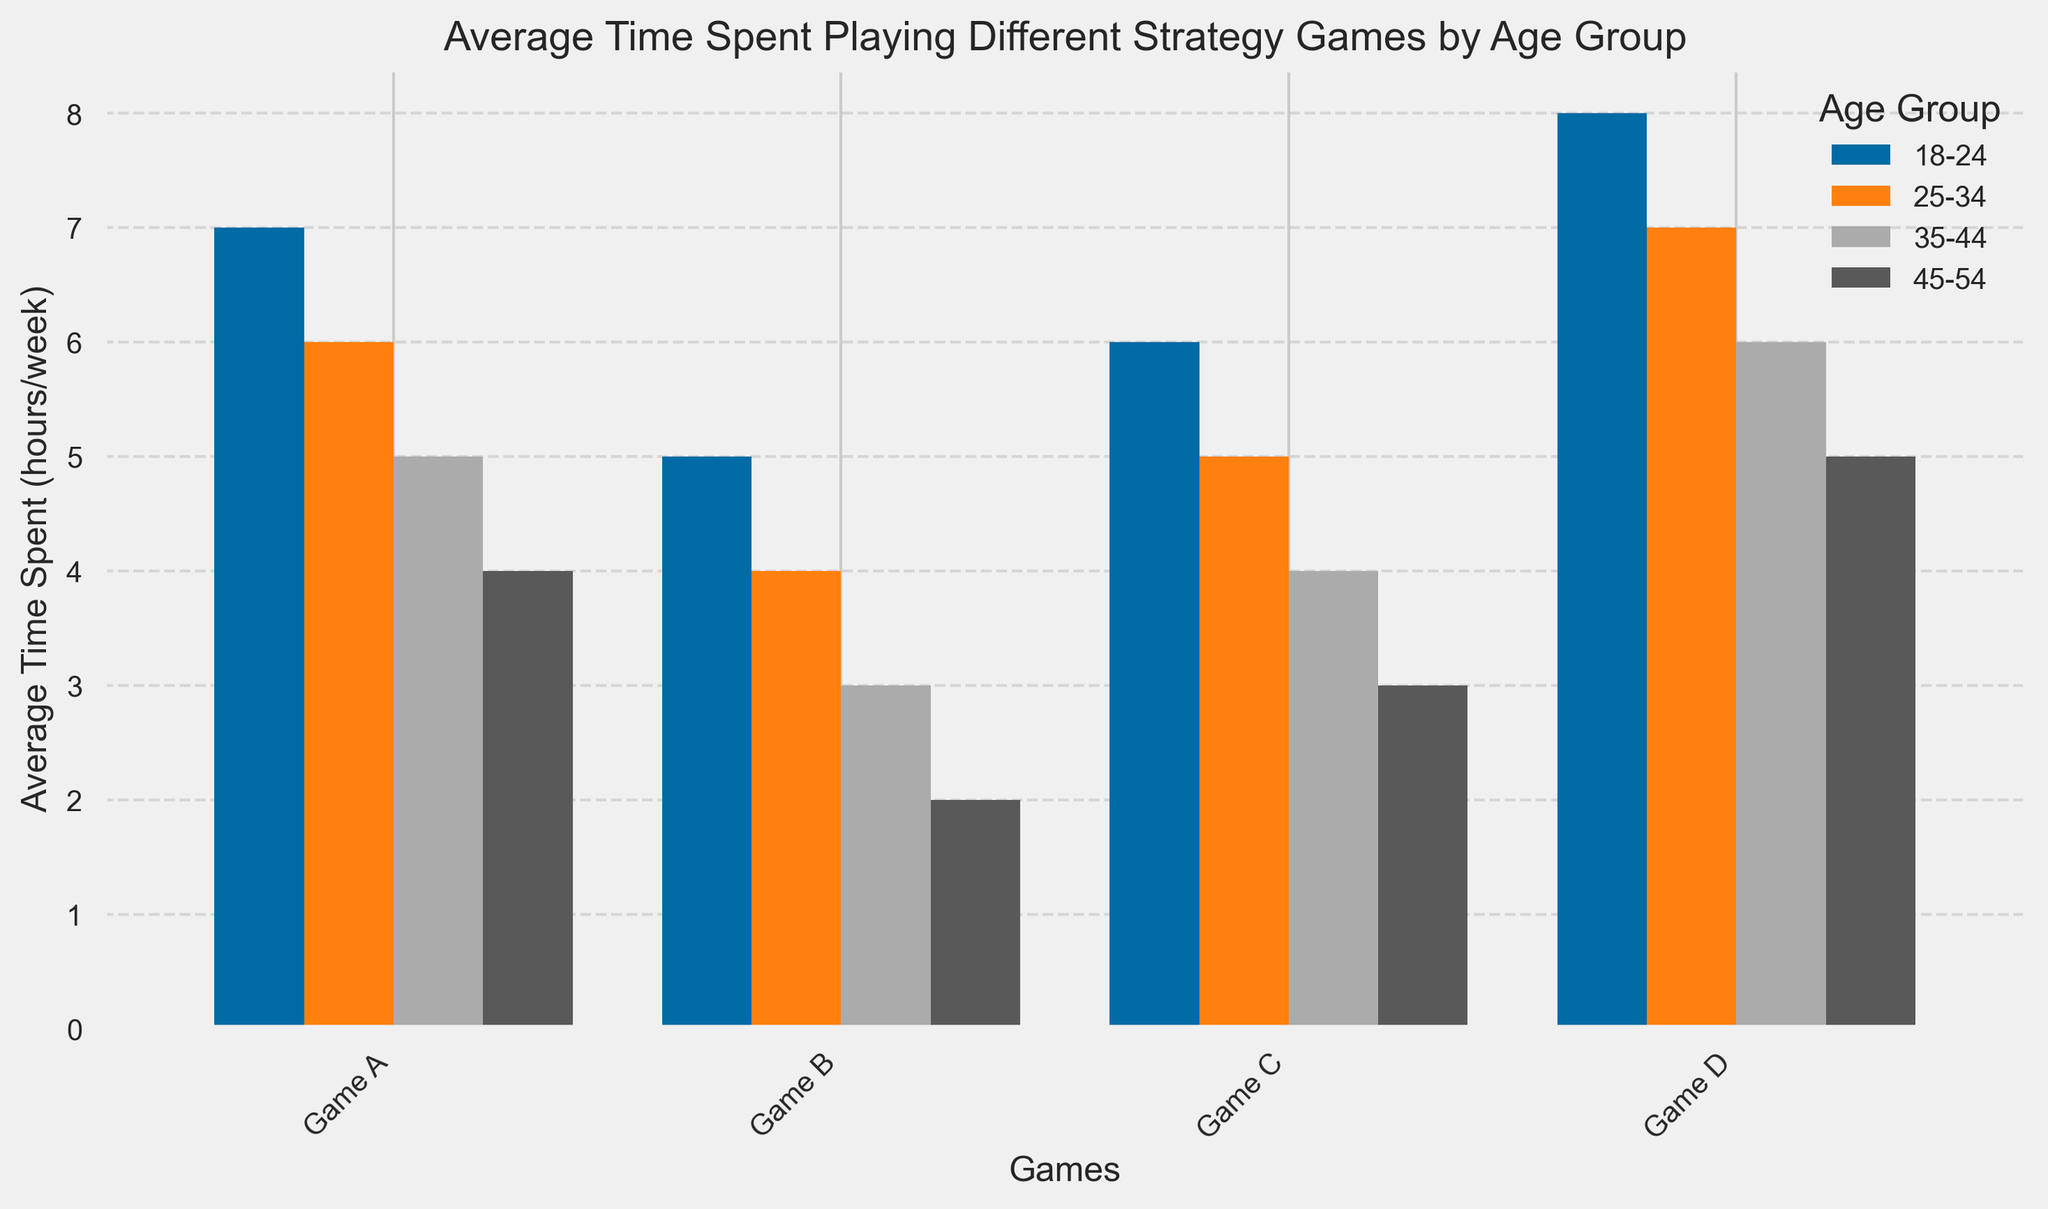Which age group spends the most average time playing Game A? By examining the bars for Game A, look at which bar is the tallest across the age groups. The tallest bar for Game A corresponds to the 18-24 age group with 7 hours/week.
Answer: 18-24 What is the total average time spent on Game D across all age groups? Sum the heights of the bars for Game D across all age groups: 8 (18-24) + 7 (25-34) + 6 (35-44) + 5 (45-54) = 26 hours/week.
Answer: 26 hours/week Which game has the smallest average time spent by the 35-44 age group? Compare the heights of the bars for the 35-44 age group across all games. Game B has the shortest bar with 3 hours/week.
Answer: Game B How does the average time spent on Game C by the 25-34 age group compare to the 45-54 age group? Look at the bars for Game C and compare the values: 5 hours/week (25-34) vs 3 hours/week (45-54). 25-34 age group spends 2 more hours per week on average than 45-54.
Answer: 2 more hours/week What is the average time spent playing Game B across all age groups? Calculate the average: sum of times for Game B (5 + 4 + 3 + 2) divided by the number of age groups (4): (5 + 4 + 3 + 2) / 4 = 3.5 hours/week.
Answer: 3.5 hours/week 